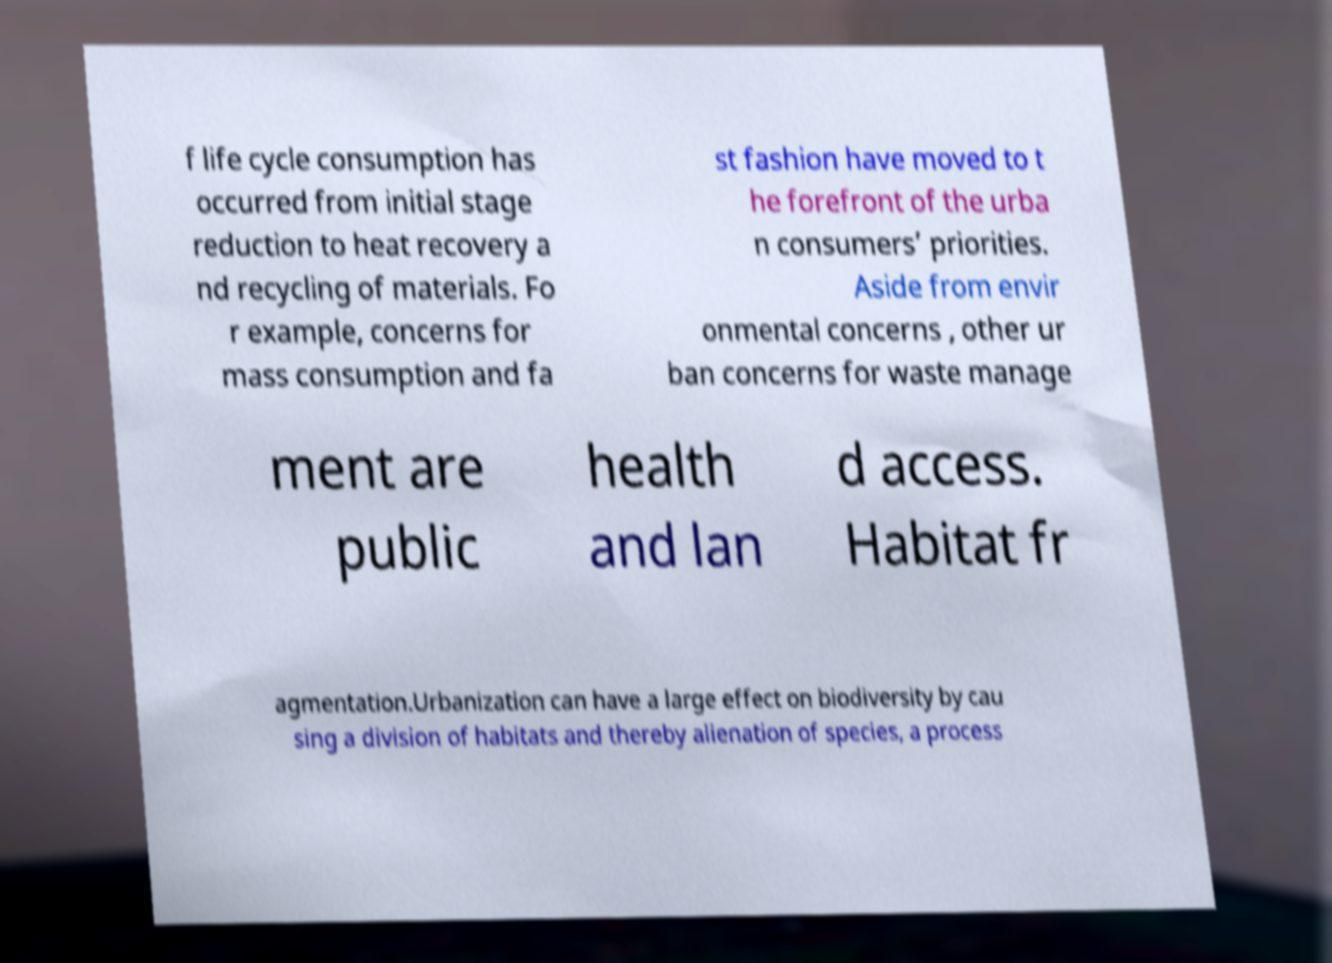Can you accurately transcribe the text from the provided image for me? f life cycle consumption has occurred from initial stage reduction to heat recovery a nd recycling of materials. Fo r example, concerns for mass consumption and fa st fashion have moved to t he forefront of the urba n consumers’ priorities. Aside from envir onmental concerns , other ur ban concerns for waste manage ment are public health and lan d access. Habitat fr agmentation.Urbanization can have a large effect on biodiversity by cau sing a division of habitats and thereby alienation of species, a process 